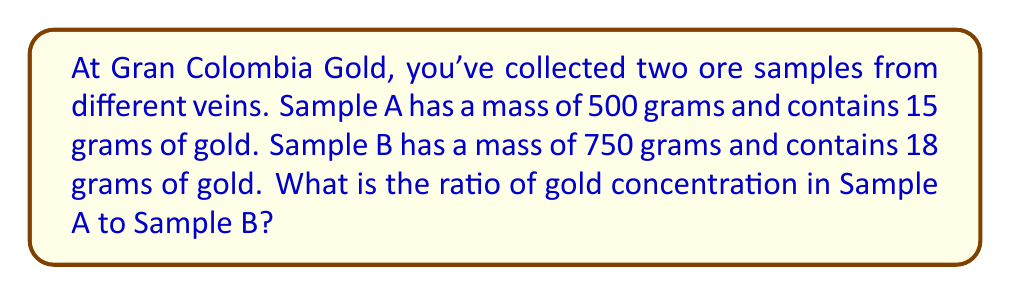Teach me how to tackle this problem. To solve this problem, we need to follow these steps:

1. Calculate the gold concentration for each sample:
   Concentration = Mass of gold / Total mass of sample

   For Sample A:
   $$ \text{Concentration}_A = \frac{15 \text{ g}}{500 \text{ g}} = 0.03 \text{ or } 3\% $$

   For Sample B:
   $$ \text{Concentration}_B = \frac{18 \text{ g}}{750 \text{ g}} = 0.024 \text{ or } 2.4\% $$

2. Express the ratio of concentrations:
   $$ \text{Ratio} = \frac{\text{Concentration}_A}{\text{Concentration}_B} = \frac{0.03}{0.024} $$

3. Simplify the ratio:
   $$ \frac{0.03}{0.024} = \frac{30}{24} = \frac{5}{4} = 1.25 $$

Therefore, the ratio of gold concentration in Sample A to Sample B is 5:4 or 1.25:1.
Answer: 5:4 or 1.25:1 